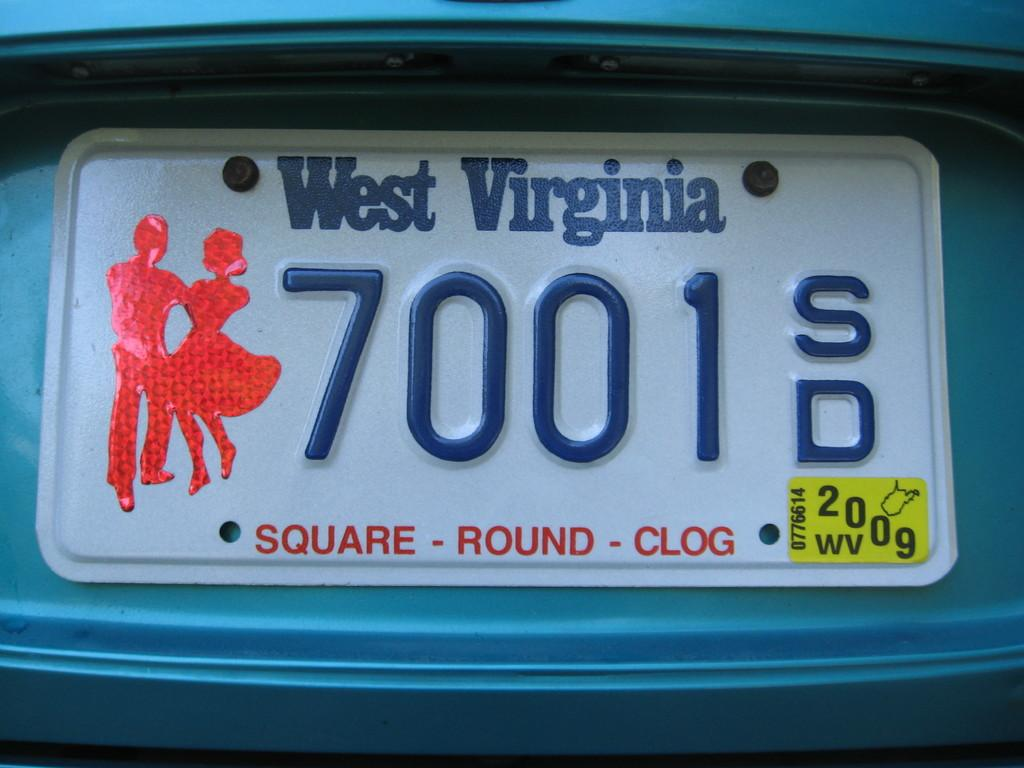<image>
Provide a brief description of the given image. a west virginia sign that has 700 on it 